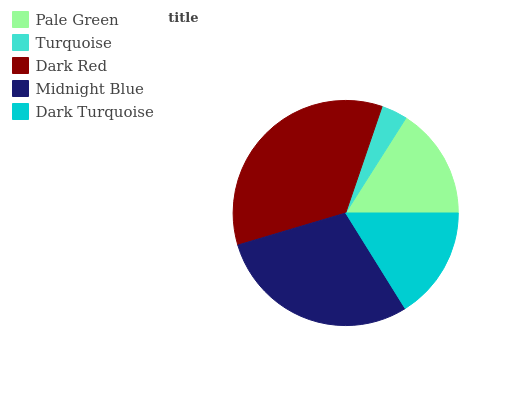Is Turquoise the minimum?
Answer yes or no. Yes. Is Dark Red the maximum?
Answer yes or no. Yes. Is Dark Red the minimum?
Answer yes or no. No. Is Turquoise the maximum?
Answer yes or no. No. Is Dark Red greater than Turquoise?
Answer yes or no. Yes. Is Turquoise less than Dark Red?
Answer yes or no. Yes. Is Turquoise greater than Dark Red?
Answer yes or no. No. Is Dark Red less than Turquoise?
Answer yes or no. No. Is Dark Turquoise the high median?
Answer yes or no. Yes. Is Dark Turquoise the low median?
Answer yes or no. Yes. Is Turquoise the high median?
Answer yes or no. No. Is Pale Green the low median?
Answer yes or no. No. 